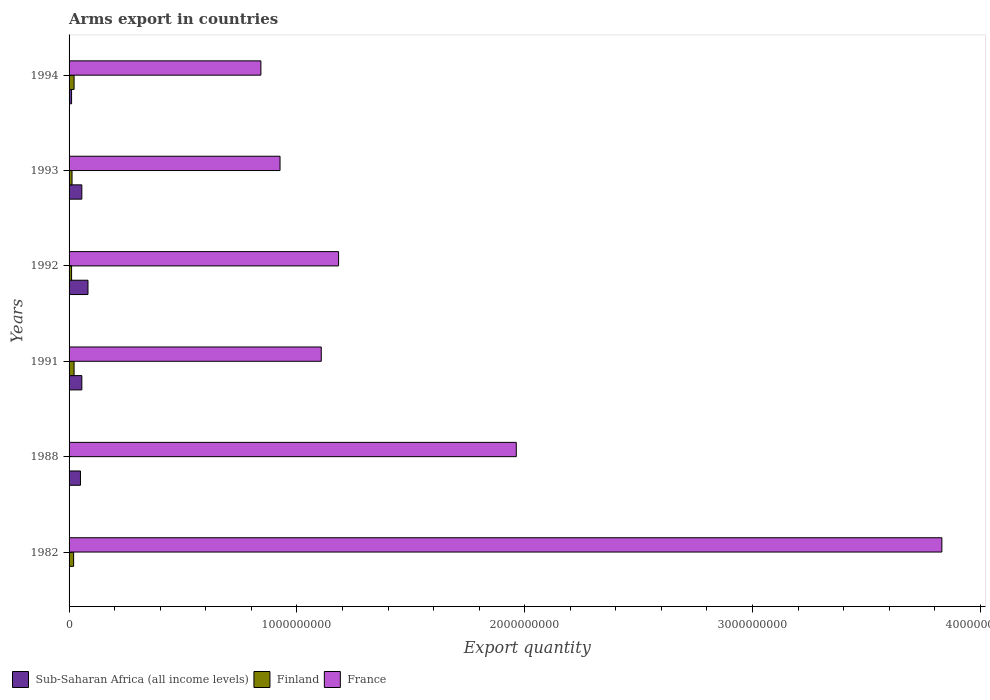How many different coloured bars are there?
Offer a terse response. 3. How many groups of bars are there?
Make the answer very short. 6. Are the number of bars per tick equal to the number of legend labels?
Give a very brief answer. Yes. How many bars are there on the 4th tick from the top?
Provide a short and direct response. 3. How many bars are there on the 2nd tick from the bottom?
Your response must be concise. 3. What is the label of the 3rd group of bars from the top?
Make the answer very short. 1992. What is the total arms export in France in 1988?
Give a very brief answer. 1.96e+09. Across all years, what is the maximum total arms export in France?
Your answer should be very brief. 3.83e+09. In which year was the total arms export in France minimum?
Ensure brevity in your answer.  1994. What is the total total arms export in Sub-Saharan Africa (all income levels) in the graph?
Make the answer very short. 2.57e+08. What is the difference between the total arms export in France in 1992 and that in 1993?
Offer a very short reply. 2.57e+08. What is the difference between the total arms export in France in 1992 and the total arms export in Finland in 1988?
Keep it short and to the point. 1.18e+09. What is the average total arms export in Finland per year?
Give a very brief answer. 1.48e+07. In the year 1994, what is the difference between the total arms export in Finland and total arms export in France?
Offer a very short reply. -8.20e+08. What is the ratio of the total arms export in France in 1988 to that in 1994?
Keep it short and to the point. 2.33. Is the total arms export in Finland in 1982 less than that in 1991?
Provide a succinct answer. Yes. Is the difference between the total arms export in Finland in 1988 and 1992 greater than the difference between the total arms export in France in 1988 and 1992?
Make the answer very short. No. What is the difference between the highest and the second highest total arms export in Sub-Saharan Africa (all income levels)?
Ensure brevity in your answer.  2.70e+07. What is the difference between the highest and the lowest total arms export in Finland?
Your response must be concise. 2.10e+07. In how many years, is the total arms export in Finland greater than the average total arms export in Finland taken over all years?
Your answer should be compact. 3. Is it the case that in every year, the sum of the total arms export in Sub-Saharan Africa (all income levels) and total arms export in France is greater than the total arms export in Finland?
Your response must be concise. Yes. How many bars are there?
Provide a succinct answer. 18. Are all the bars in the graph horizontal?
Provide a succinct answer. Yes. Does the graph contain grids?
Provide a short and direct response. No. How many legend labels are there?
Make the answer very short. 3. What is the title of the graph?
Make the answer very short. Arms export in countries. What is the label or title of the X-axis?
Offer a very short reply. Export quantity. What is the label or title of the Y-axis?
Provide a short and direct response. Years. What is the Export quantity of Finland in 1982?
Your response must be concise. 2.00e+07. What is the Export quantity of France in 1982?
Offer a terse response. 3.83e+09. What is the Export quantity in Finland in 1988?
Your answer should be compact. 1.00e+06. What is the Export quantity of France in 1988?
Offer a very short reply. 1.96e+09. What is the Export quantity of Sub-Saharan Africa (all income levels) in 1991?
Offer a terse response. 5.60e+07. What is the Export quantity in Finland in 1991?
Ensure brevity in your answer.  2.20e+07. What is the Export quantity in France in 1991?
Keep it short and to the point. 1.11e+09. What is the Export quantity in Sub-Saharan Africa (all income levels) in 1992?
Ensure brevity in your answer.  8.30e+07. What is the Export quantity of Finland in 1992?
Your response must be concise. 1.10e+07. What is the Export quantity in France in 1992?
Offer a very short reply. 1.18e+09. What is the Export quantity in Sub-Saharan Africa (all income levels) in 1993?
Provide a succinct answer. 5.60e+07. What is the Export quantity in Finland in 1993?
Keep it short and to the point. 1.30e+07. What is the Export quantity of France in 1993?
Offer a very short reply. 9.26e+08. What is the Export quantity of Sub-Saharan Africa (all income levels) in 1994?
Give a very brief answer. 1.10e+07. What is the Export quantity in Finland in 1994?
Offer a very short reply. 2.20e+07. What is the Export quantity in France in 1994?
Offer a very short reply. 8.42e+08. Across all years, what is the maximum Export quantity of Sub-Saharan Africa (all income levels)?
Your response must be concise. 8.30e+07. Across all years, what is the maximum Export quantity of Finland?
Your answer should be very brief. 2.20e+07. Across all years, what is the maximum Export quantity in France?
Ensure brevity in your answer.  3.83e+09. Across all years, what is the minimum Export quantity in Sub-Saharan Africa (all income levels)?
Offer a very short reply. 1.00e+06. Across all years, what is the minimum Export quantity in France?
Give a very brief answer. 8.42e+08. What is the total Export quantity of Sub-Saharan Africa (all income levels) in the graph?
Provide a short and direct response. 2.57e+08. What is the total Export quantity of Finland in the graph?
Give a very brief answer. 8.90e+07. What is the total Export quantity in France in the graph?
Provide a succinct answer. 9.85e+09. What is the difference between the Export quantity in Sub-Saharan Africa (all income levels) in 1982 and that in 1988?
Make the answer very short. -4.90e+07. What is the difference between the Export quantity in Finland in 1982 and that in 1988?
Your response must be concise. 1.90e+07. What is the difference between the Export quantity of France in 1982 and that in 1988?
Make the answer very short. 1.87e+09. What is the difference between the Export quantity of Sub-Saharan Africa (all income levels) in 1982 and that in 1991?
Give a very brief answer. -5.50e+07. What is the difference between the Export quantity of Finland in 1982 and that in 1991?
Your answer should be very brief. -2.00e+06. What is the difference between the Export quantity in France in 1982 and that in 1991?
Offer a very short reply. 2.72e+09. What is the difference between the Export quantity of Sub-Saharan Africa (all income levels) in 1982 and that in 1992?
Make the answer very short. -8.20e+07. What is the difference between the Export quantity in Finland in 1982 and that in 1992?
Keep it short and to the point. 9.00e+06. What is the difference between the Export quantity in France in 1982 and that in 1992?
Give a very brief answer. 2.65e+09. What is the difference between the Export quantity of Sub-Saharan Africa (all income levels) in 1982 and that in 1993?
Your answer should be compact. -5.50e+07. What is the difference between the Export quantity of Finland in 1982 and that in 1993?
Provide a succinct answer. 7.00e+06. What is the difference between the Export quantity of France in 1982 and that in 1993?
Offer a very short reply. 2.90e+09. What is the difference between the Export quantity of Sub-Saharan Africa (all income levels) in 1982 and that in 1994?
Ensure brevity in your answer.  -1.00e+07. What is the difference between the Export quantity of France in 1982 and that in 1994?
Your response must be concise. 2.99e+09. What is the difference between the Export quantity in Sub-Saharan Africa (all income levels) in 1988 and that in 1991?
Make the answer very short. -6.00e+06. What is the difference between the Export quantity of Finland in 1988 and that in 1991?
Provide a succinct answer. -2.10e+07. What is the difference between the Export quantity of France in 1988 and that in 1991?
Ensure brevity in your answer.  8.56e+08. What is the difference between the Export quantity of Sub-Saharan Africa (all income levels) in 1988 and that in 1992?
Your response must be concise. -3.30e+07. What is the difference between the Export quantity in Finland in 1988 and that in 1992?
Ensure brevity in your answer.  -1.00e+07. What is the difference between the Export quantity of France in 1988 and that in 1992?
Offer a very short reply. 7.80e+08. What is the difference between the Export quantity of Sub-Saharan Africa (all income levels) in 1988 and that in 1993?
Make the answer very short. -6.00e+06. What is the difference between the Export quantity of Finland in 1988 and that in 1993?
Ensure brevity in your answer.  -1.20e+07. What is the difference between the Export quantity in France in 1988 and that in 1993?
Your response must be concise. 1.04e+09. What is the difference between the Export quantity of Sub-Saharan Africa (all income levels) in 1988 and that in 1994?
Ensure brevity in your answer.  3.90e+07. What is the difference between the Export quantity of Finland in 1988 and that in 1994?
Provide a short and direct response. -2.10e+07. What is the difference between the Export quantity in France in 1988 and that in 1994?
Your response must be concise. 1.12e+09. What is the difference between the Export quantity of Sub-Saharan Africa (all income levels) in 1991 and that in 1992?
Ensure brevity in your answer.  -2.70e+07. What is the difference between the Export quantity of Finland in 1991 and that in 1992?
Offer a terse response. 1.10e+07. What is the difference between the Export quantity of France in 1991 and that in 1992?
Provide a short and direct response. -7.60e+07. What is the difference between the Export quantity in Finland in 1991 and that in 1993?
Make the answer very short. 9.00e+06. What is the difference between the Export quantity of France in 1991 and that in 1993?
Offer a terse response. 1.81e+08. What is the difference between the Export quantity of Sub-Saharan Africa (all income levels) in 1991 and that in 1994?
Provide a short and direct response. 4.50e+07. What is the difference between the Export quantity of France in 1991 and that in 1994?
Give a very brief answer. 2.65e+08. What is the difference between the Export quantity in Sub-Saharan Africa (all income levels) in 1992 and that in 1993?
Offer a very short reply. 2.70e+07. What is the difference between the Export quantity of France in 1992 and that in 1993?
Offer a terse response. 2.57e+08. What is the difference between the Export quantity in Sub-Saharan Africa (all income levels) in 1992 and that in 1994?
Make the answer very short. 7.20e+07. What is the difference between the Export quantity in Finland in 1992 and that in 1994?
Make the answer very short. -1.10e+07. What is the difference between the Export quantity in France in 1992 and that in 1994?
Offer a very short reply. 3.41e+08. What is the difference between the Export quantity in Sub-Saharan Africa (all income levels) in 1993 and that in 1994?
Give a very brief answer. 4.50e+07. What is the difference between the Export quantity in Finland in 1993 and that in 1994?
Offer a very short reply. -9.00e+06. What is the difference between the Export quantity of France in 1993 and that in 1994?
Ensure brevity in your answer.  8.40e+07. What is the difference between the Export quantity in Sub-Saharan Africa (all income levels) in 1982 and the Export quantity in Finland in 1988?
Provide a short and direct response. 0. What is the difference between the Export quantity of Sub-Saharan Africa (all income levels) in 1982 and the Export quantity of France in 1988?
Make the answer very short. -1.96e+09. What is the difference between the Export quantity in Finland in 1982 and the Export quantity in France in 1988?
Your answer should be compact. -1.94e+09. What is the difference between the Export quantity of Sub-Saharan Africa (all income levels) in 1982 and the Export quantity of Finland in 1991?
Keep it short and to the point. -2.10e+07. What is the difference between the Export quantity of Sub-Saharan Africa (all income levels) in 1982 and the Export quantity of France in 1991?
Ensure brevity in your answer.  -1.11e+09. What is the difference between the Export quantity of Finland in 1982 and the Export quantity of France in 1991?
Keep it short and to the point. -1.09e+09. What is the difference between the Export quantity of Sub-Saharan Africa (all income levels) in 1982 and the Export quantity of Finland in 1992?
Provide a succinct answer. -1.00e+07. What is the difference between the Export quantity of Sub-Saharan Africa (all income levels) in 1982 and the Export quantity of France in 1992?
Offer a terse response. -1.18e+09. What is the difference between the Export quantity of Finland in 1982 and the Export quantity of France in 1992?
Offer a terse response. -1.16e+09. What is the difference between the Export quantity of Sub-Saharan Africa (all income levels) in 1982 and the Export quantity of Finland in 1993?
Give a very brief answer. -1.20e+07. What is the difference between the Export quantity of Sub-Saharan Africa (all income levels) in 1982 and the Export quantity of France in 1993?
Your answer should be compact. -9.25e+08. What is the difference between the Export quantity in Finland in 1982 and the Export quantity in France in 1993?
Your answer should be very brief. -9.06e+08. What is the difference between the Export quantity in Sub-Saharan Africa (all income levels) in 1982 and the Export quantity in Finland in 1994?
Ensure brevity in your answer.  -2.10e+07. What is the difference between the Export quantity of Sub-Saharan Africa (all income levels) in 1982 and the Export quantity of France in 1994?
Ensure brevity in your answer.  -8.41e+08. What is the difference between the Export quantity in Finland in 1982 and the Export quantity in France in 1994?
Your response must be concise. -8.22e+08. What is the difference between the Export quantity of Sub-Saharan Africa (all income levels) in 1988 and the Export quantity of Finland in 1991?
Provide a succinct answer. 2.80e+07. What is the difference between the Export quantity of Sub-Saharan Africa (all income levels) in 1988 and the Export quantity of France in 1991?
Keep it short and to the point. -1.06e+09. What is the difference between the Export quantity in Finland in 1988 and the Export quantity in France in 1991?
Keep it short and to the point. -1.11e+09. What is the difference between the Export quantity of Sub-Saharan Africa (all income levels) in 1988 and the Export quantity of Finland in 1992?
Your response must be concise. 3.90e+07. What is the difference between the Export quantity in Sub-Saharan Africa (all income levels) in 1988 and the Export quantity in France in 1992?
Ensure brevity in your answer.  -1.13e+09. What is the difference between the Export quantity of Finland in 1988 and the Export quantity of France in 1992?
Your answer should be compact. -1.18e+09. What is the difference between the Export quantity in Sub-Saharan Africa (all income levels) in 1988 and the Export quantity in Finland in 1993?
Your response must be concise. 3.70e+07. What is the difference between the Export quantity of Sub-Saharan Africa (all income levels) in 1988 and the Export quantity of France in 1993?
Make the answer very short. -8.76e+08. What is the difference between the Export quantity in Finland in 1988 and the Export quantity in France in 1993?
Provide a succinct answer. -9.25e+08. What is the difference between the Export quantity in Sub-Saharan Africa (all income levels) in 1988 and the Export quantity in Finland in 1994?
Provide a succinct answer. 2.80e+07. What is the difference between the Export quantity of Sub-Saharan Africa (all income levels) in 1988 and the Export quantity of France in 1994?
Your answer should be compact. -7.92e+08. What is the difference between the Export quantity of Finland in 1988 and the Export quantity of France in 1994?
Your answer should be very brief. -8.41e+08. What is the difference between the Export quantity of Sub-Saharan Africa (all income levels) in 1991 and the Export quantity of Finland in 1992?
Your answer should be compact. 4.50e+07. What is the difference between the Export quantity of Sub-Saharan Africa (all income levels) in 1991 and the Export quantity of France in 1992?
Provide a short and direct response. -1.13e+09. What is the difference between the Export quantity in Finland in 1991 and the Export quantity in France in 1992?
Give a very brief answer. -1.16e+09. What is the difference between the Export quantity in Sub-Saharan Africa (all income levels) in 1991 and the Export quantity in Finland in 1993?
Give a very brief answer. 4.30e+07. What is the difference between the Export quantity of Sub-Saharan Africa (all income levels) in 1991 and the Export quantity of France in 1993?
Offer a very short reply. -8.70e+08. What is the difference between the Export quantity in Finland in 1991 and the Export quantity in France in 1993?
Offer a very short reply. -9.04e+08. What is the difference between the Export quantity in Sub-Saharan Africa (all income levels) in 1991 and the Export quantity in Finland in 1994?
Offer a very short reply. 3.40e+07. What is the difference between the Export quantity of Sub-Saharan Africa (all income levels) in 1991 and the Export quantity of France in 1994?
Provide a short and direct response. -7.86e+08. What is the difference between the Export quantity in Finland in 1991 and the Export quantity in France in 1994?
Give a very brief answer. -8.20e+08. What is the difference between the Export quantity in Sub-Saharan Africa (all income levels) in 1992 and the Export quantity in Finland in 1993?
Your response must be concise. 7.00e+07. What is the difference between the Export quantity of Sub-Saharan Africa (all income levels) in 1992 and the Export quantity of France in 1993?
Your answer should be very brief. -8.43e+08. What is the difference between the Export quantity of Finland in 1992 and the Export quantity of France in 1993?
Provide a succinct answer. -9.15e+08. What is the difference between the Export quantity in Sub-Saharan Africa (all income levels) in 1992 and the Export quantity in Finland in 1994?
Provide a succinct answer. 6.10e+07. What is the difference between the Export quantity in Sub-Saharan Africa (all income levels) in 1992 and the Export quantity in France in 1994?
Provide a succinct answer. -7.59e+08. What is the difference between the Export quantity in Finland in 1992 and the Export quantity in France in 1994?
Your response must be concise. -8.31e+08. What is the difference between the Export quantity in Sub-Saharan Africa (all income levels) in 1993 and the Export quantity in Finland in 1994?
Give a very brief answer. 3.40e+07. What is the difference between the Export quantity in Sub-Saharan Africa (all income levels) in 1993 and the Export quantity in France in 1994?
Provide a short and direct response. -7.86e+08. What is the difference between the Export quantity of Finland in 1993 and the Export quantity of France in 1994?
Ensure brevity in your answer.  -8.29e+08. What is the average Export quantity in Sub-Saharan Africa (all income levels) per year?
Keep it short and to the point. 4.28e+07. What is the average Export quantity in Finland per year?
Offer a terse response. 1.48e+07. What is the average Export quantity of France per year?
Provide a succinct answer. 1.64e+09. In the year 1982, what is the difference between the Export quantity in Sub-Saharan Africa (all income levels) and Export quantity in Finland?
Your answer should be compact. -1.90e+07. In the year 1982, what is the difference between the Export quantity of Sub-Saharan Africa (all income levels) and Export quantity of France?
Your response must be concise. -3.83e+09. In the year 1982, what is the difference between the Export quantity of Finland and Export quantity of France?
Keep it short and to the point. -3.81e+09. In the year 1988, what is the difference between the Export quantity of Sub-Saharan Africa (all income levels) and Export quantity of Finland?
Offer a very short reply. 4.90e+07. In the year 1988, what is the difference between the Export quantity of Sub-Saharan Africa (all income levels) and Export quantity of France?
Ensure brevity in your answer.  -1.91e+09. In the year 1988, what is the difference between the Export quantity in Finland and Export quantity in France?
Ensure brevity in your answer.  -1.96e+09. In the year 1991, what is the difference between the Export quantity of Sub-Saharan Africa (all income levels) and Export quantity of Finland?
Offer a very short reply. 3.40e+07. In the year 1991, what is the difference between the Export quantity of Sub-Saharan Africa (all income levels) and Export quantity of France?
Offer a very short reply. -1.05e+09. In the year 1991, what is the difference between the Export quantity in Finland and Export quantity in France?
Offer a terse response. -1.08e+09. In the year 1992, what is the difference between the Export quantity of Sub-Saharan Africa (all income levels) and Export quantity of Finland?
Provide a succinct answer. 7.20e+07. In the year 1992, what is the difference between the Export quantity in Sub-Saharan Africa (all income levels) and Export quantity in France?
Offer a very short reply. -1.10e+09. In the year 1992, what is the difference between the Export quantity of Finland and Export quantity of France?
Offer a very short reply. -1.17e+09. In the year 1993, what is the difference between the Export quantity of Sub-Saharan Africa (all income levels) and Export quantity of Finland?
Provide a short and direct response. 4.30e+07. In the year 1993, what is the difference between the Export quantity of Sub-Saharan Africa (all income levels) and Export quantity of France?
Your answer should be compact. -8.70e+08. In the year 1993, what is the difference between the Export quantity of Finland and Export quantity of France?
Your response must be concise. -9.13e+08. In the year 1994, what is the difference between the Export quantity of Sub-Saharan Africa (all income levels) and Export quantity of Finland?
Provide a succinct answer. -1.10e+07. In the year 1994, what is the difference between the Export quantity in Sub-Saharan Africa (all income levels) and Export quantity in France?
Ensure brevity in your answer.  -8.31e+08. In the year 1994, what is the difference between the Export quantity in Finland and Export quantity in France?
Keep it short and to the point. -8.20e+08. What is the ratio of the Export quantity in Sub-Saharan Africa (all income levels) in 1982 to that in 1988?
Offer a very short reply. 0.02. What is the ratio of the Export quantity of France in 1982 to that in 1988?
Provide a short and direct response. 1.95. What is the ratio of the Export quantity of Sub-Saharan Africa (all income levels) in 1982 to that in 1991?
Make the answer very short. 0.02. What is the ratio of the Export quantity of Finland in 1982 to that in 1991?
Your response must be concise. 0.91. What is the ratio of the Export quantity in France in 1982 to that in 1991?
Your answer should be very brief. 3.46. What is the ratio of the Export quantity in Sub-Saharan Africa (all income levels) in 1982 to that in 1992?
Your answer should be very brief. 0.01. What is the ratio of the Export quantity in Finland in 1982 to that in 1992?
Keep it short and to the point. 1.82. What is the ratio of the Export quantity of France in 1982 to that in 1992?
Your response must be concise. 3.24. What is the ratio of the Export quantity in Sub-Saharan Africa (all income levels) in 1982 to that in 1993?
Ensure brevity in your answer.  0.02. What is the ratio of the Export quantity in Finland in 1982 to that in 1993?
Make the answer very short. 1.54. What is the ratio of the Export quantity of France in 1982 to that in 1993?
Offer a terse response. 4.14. What is the ratio of the Export quantity in Sub-Saharan Africa (all income levels) in 1982 to that in 1994?
Provide a short and direct response. 0.09. What is the ratio of the Export quantity in France in 1982 to that in 1994?
Your response must be concise. 4.55. What is the ratio of the Export quantity in Sub-Saharan Africa (all income levels) in 1988 to that in 1991?
Make the answer very short. 0.89. What is the ratio of the Export quantity of Finland in 1988 to that in 1991?
Give a very brief answer. 0.05. What is the ratio of the Export quantity of France in 1988 to that in 1991?
Keep it short and to the point. 1.77. What is the ratio of the Export quantity in Sub-Saharan Africa (all income levels) in 1988 to that in 1992?
Provide a short and direct response. 0.6. What is the ratio of the Export quantity in Finland in 1988 to that in 1992?
Offer a very short reply. 0.09. What is the ratio of the Export quantity of France in 1988 to that in 1992?
Make the answer very short. 1.66. What is the ratio of the Export quantity of Sub-Saharan Africa (all income levels) in 1988 to that in 1993?
Make the answer very short. 0.89. What is the ratio of the Export quantity in Finland in 1988 to that in 1993?
Provide a succinct answer. 0.08. What is the ratio of the Export quantity in France in 1988 to that in 1993?
Keep it short and to the point. 2.12. What is the ratio of the Export quantity in Sub-Saharan Africa (all income levels) in 1988 to that in 1994?
Your answer should be compact. 4.55. What is the ratio of the Export quantity of Finland in 1988 to that in 1994?
Your response must be concise. 0.05. What is the ratio of the Export quantity of France in 1988 to that in 1994?
Ensure brevity in your answer.  2.33. What is the ratio of the Export quantity in Sub-Saharan Africa (all income levels) in 1991 to that in 1992?
Make the answer very short. 0.67. What is the ratio of the Export quantity in Finland in 1991 to that in 1992?
Ensure brevity in your answer.  2. What is the ratio of the Export quantity in France in 1991 to that in 1992?
Give a very brief answer. 0.94. What is the ratio of the Export quantity of Sub-Saharan Africa (all income levels) in 1991 to that in 1993?
Give a very brief answer. 1. What is the ratio of the Export quantity of Finland in 1991 to that in 1993?
Keep it short and to the point. 1.69. What is the ratio of the Export quantity of France in 1991 to that in 1993?
Provide a short and direct response. 1.2. What is the ratio of the Export quantity in Sub-Saharan Africa (all income levels) in 1991 to that in 1994?
Offer a terse response. 5.09. What is the ratio of the Export quantity of France in 1991 to that in 1994?
Make the answer very short. 1.31. What is the ratio of the Export quantity of Sub-Saharan Africa (all income levels) in 1992 to that in 1993?
Your answer should be compact. 1.48. What is the ratio of the Export quantity of Finland in 1992 to that in 1993?
Ensure brevity in your answer.  0.85. What is the ratio of the Export quantity of France in 1992 to that in 1993?
Your answer should be compact. 1.28. What is the ratio of the Export quantity of Sub-Saharan Africa (all income levels) in 1992 to that in 1994?
Give a very brief answer. 7.55. What is the ratio of the Export quantity of France in 1992 to that in 1994?
Provide a short and direct response. 1.41. What is the ratio of the Export quantity of Sub-Saharan Africa (all income levels) in 1993 to that in 1994?
Ensure brevity in your answer.  5.09. What is the ratio of the Export quantity of Finland in 1993 to that in 1994?
Give a very brief answer. 0.59. What is the ratio of the Export quantity in France in 1993 to that in 1994?
Make the answer very short. 1.1. What is the difference between the highest and the second highest Export quantity of Sub-Saharan Africa (all income levels)?
Provide a succinct answer. 2.70e+07. What is the difference between the highest and the second highest Export quantity of Finland?
Keep it short and to the point. 0. What is the difference between the highest and the second highest Export quantity of France?
Ensure brevity in your answer.  1.87e+09. What is the difference between the highest and the lowest Export quantity of Sub-Saharan Africa (all income levels)?
Your response must be concise. 8.20e+07. What is the difference between the highest and the lowest Export quantity of Finland?
Offer a very short reply. 2.10e+07. What is the difference between the highest and the lowest Export quantity of France?
Provide a short and direct response. 2.99e+09. 